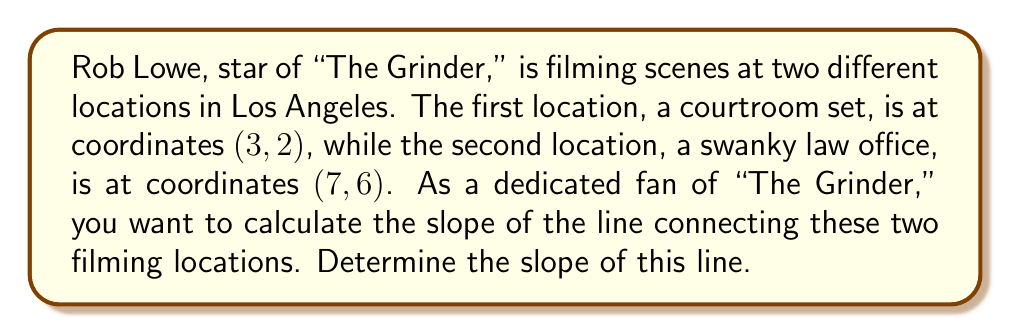Provide a solution to this math problem. To find the slope of a line connecting two points, we use the slope formula:

$$ m = \frac{y_2 - y_1}{x_2 - x_1} $$

Where $(x_1, y_1)$ is the first point and $(x_2, y_2)$ is the second point.

For this problem:
- Point 1 (courtroom set): $(x_1, y_1) = (3, 2)$
- Point 2 (law office): $(x_2, y_2) = (7, 6)$

Let's substitute these values into the slope formula:

$$ m = \frac{6 - 2}{7 - 3} $$

Simplifying:

$$ m = \frac{4}{4} $$

$$ m = 1 $$

Therefore, the slope of the line connecting the two filming locations is 1.

This means that for every 1 unit increase in the x-direction, there is a 1 unit increase in the y-direction, creating a perfect 45-degree angle. Just as "The Grinder" always finds the perfect angle to win his cases!
Answer: $m = 1$ 